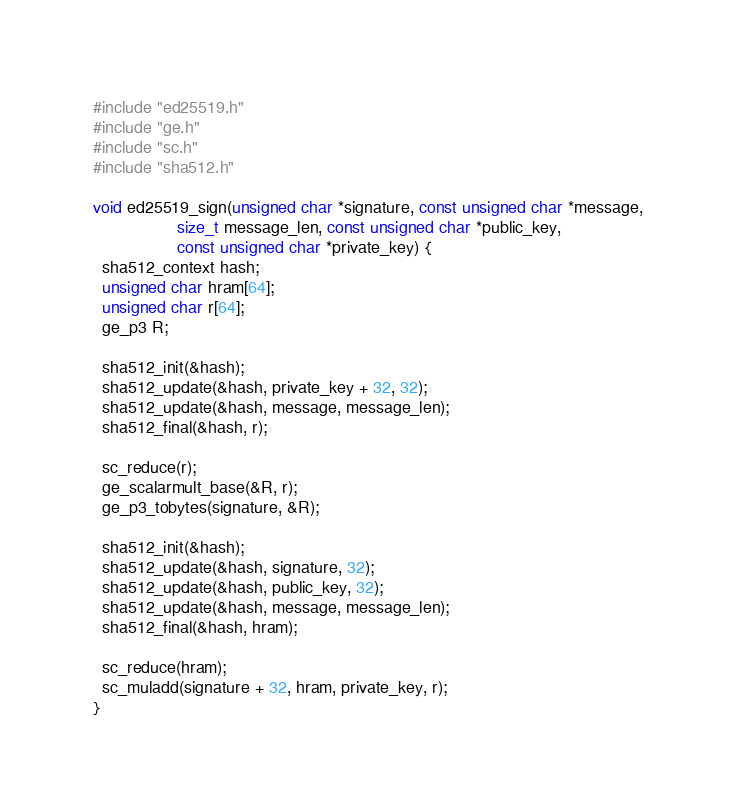<code> <loc_0><loc_0><loc_500><loc_500><_C_>#include "ed25519.h"
#include "ge.h"
#include "sc.h"
#include "sha512.h"

void ed25519_sign(unsigned char *signature, const unsigned char *message,
                  size_t message_len, const unsigned char *public_key,
                  const unsigned char *private_key) {
  sha512_context hash;
  unsigned char hram[64];
  unsigned char r[64];
  ge_p3 R;

  sha512_init(&hash);
  sha512_update(&hash, private_key + 32, 32);
  sha512_update(&hash, message, message_len);
  sha512_final(&hash, r);

  sc_reduce(r);
  ge_scalarmult_base(&R, r);
  ge_p3_tobytes(signature, &R);

  sha512_init(&hash);
  sha512_update(&hash, signature, 32);
  sha512_update(&hash, public_key, 32);
  sha512_update(&hash, message, message_len);
  sha512_final(&hash, hram);

  sc_reduce(hram);
  sc_muladd(signature + 32, hram, private_key, r);
}
</code> 